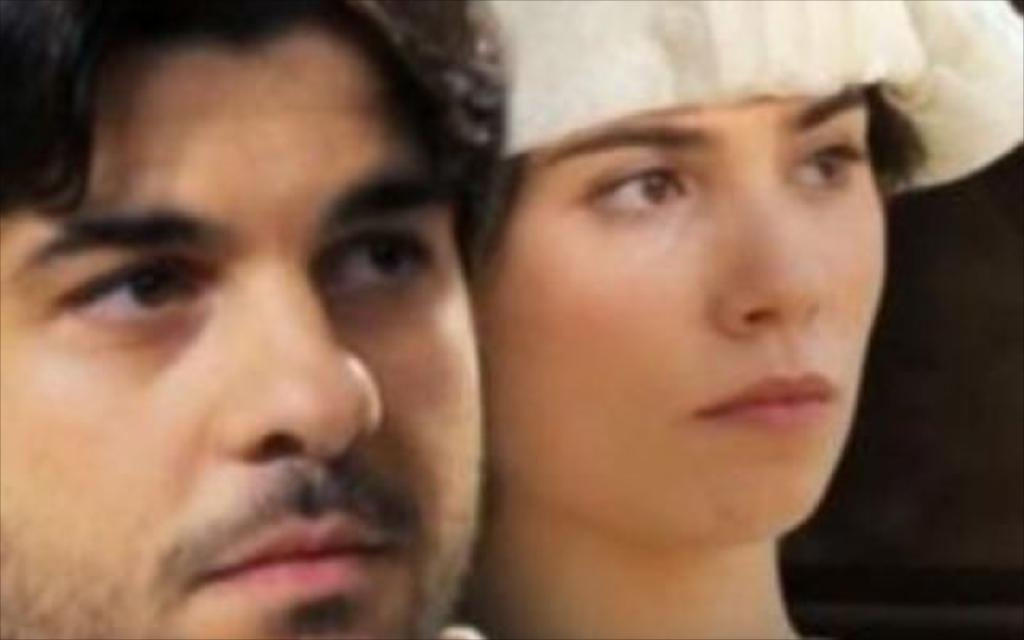What can be seen in the image? There is a boy's face and a girl's face in the image. What is the color of the background in the image? The background of the image is dark. What type of pin can be seen in the image? There is no pin present in the image. What is the health condition of the boy and girl in the image? We cannot determine the health condition of the boy and girl in the image based on the provided facts. 